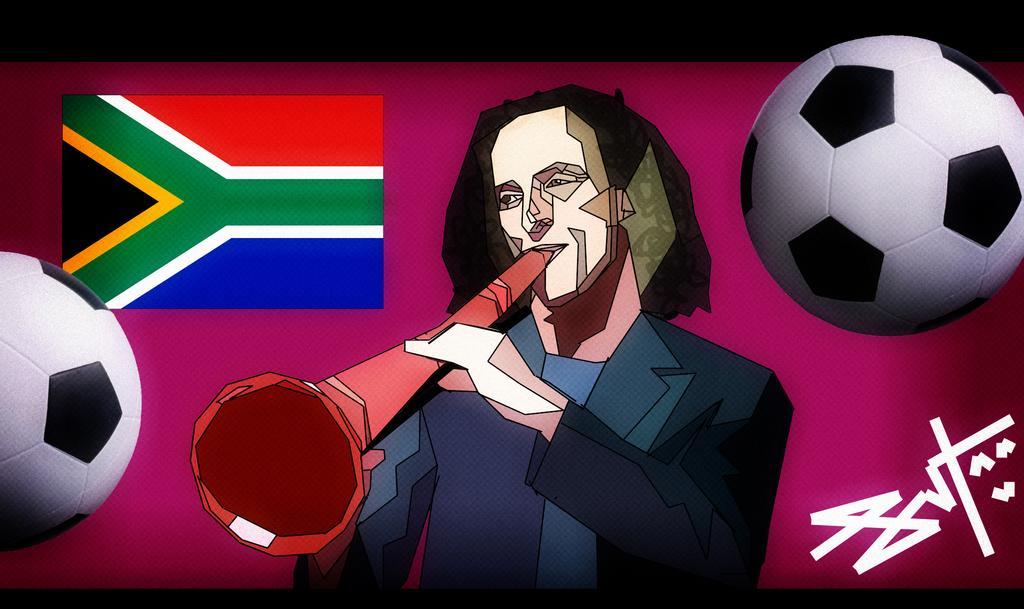Can you describe this image briefly? In the picture we can see a cartoon image of a man playing a musical instrument and besides him we can see a flag and on both the sides we can see football images and to the bottom we can see a signature. 